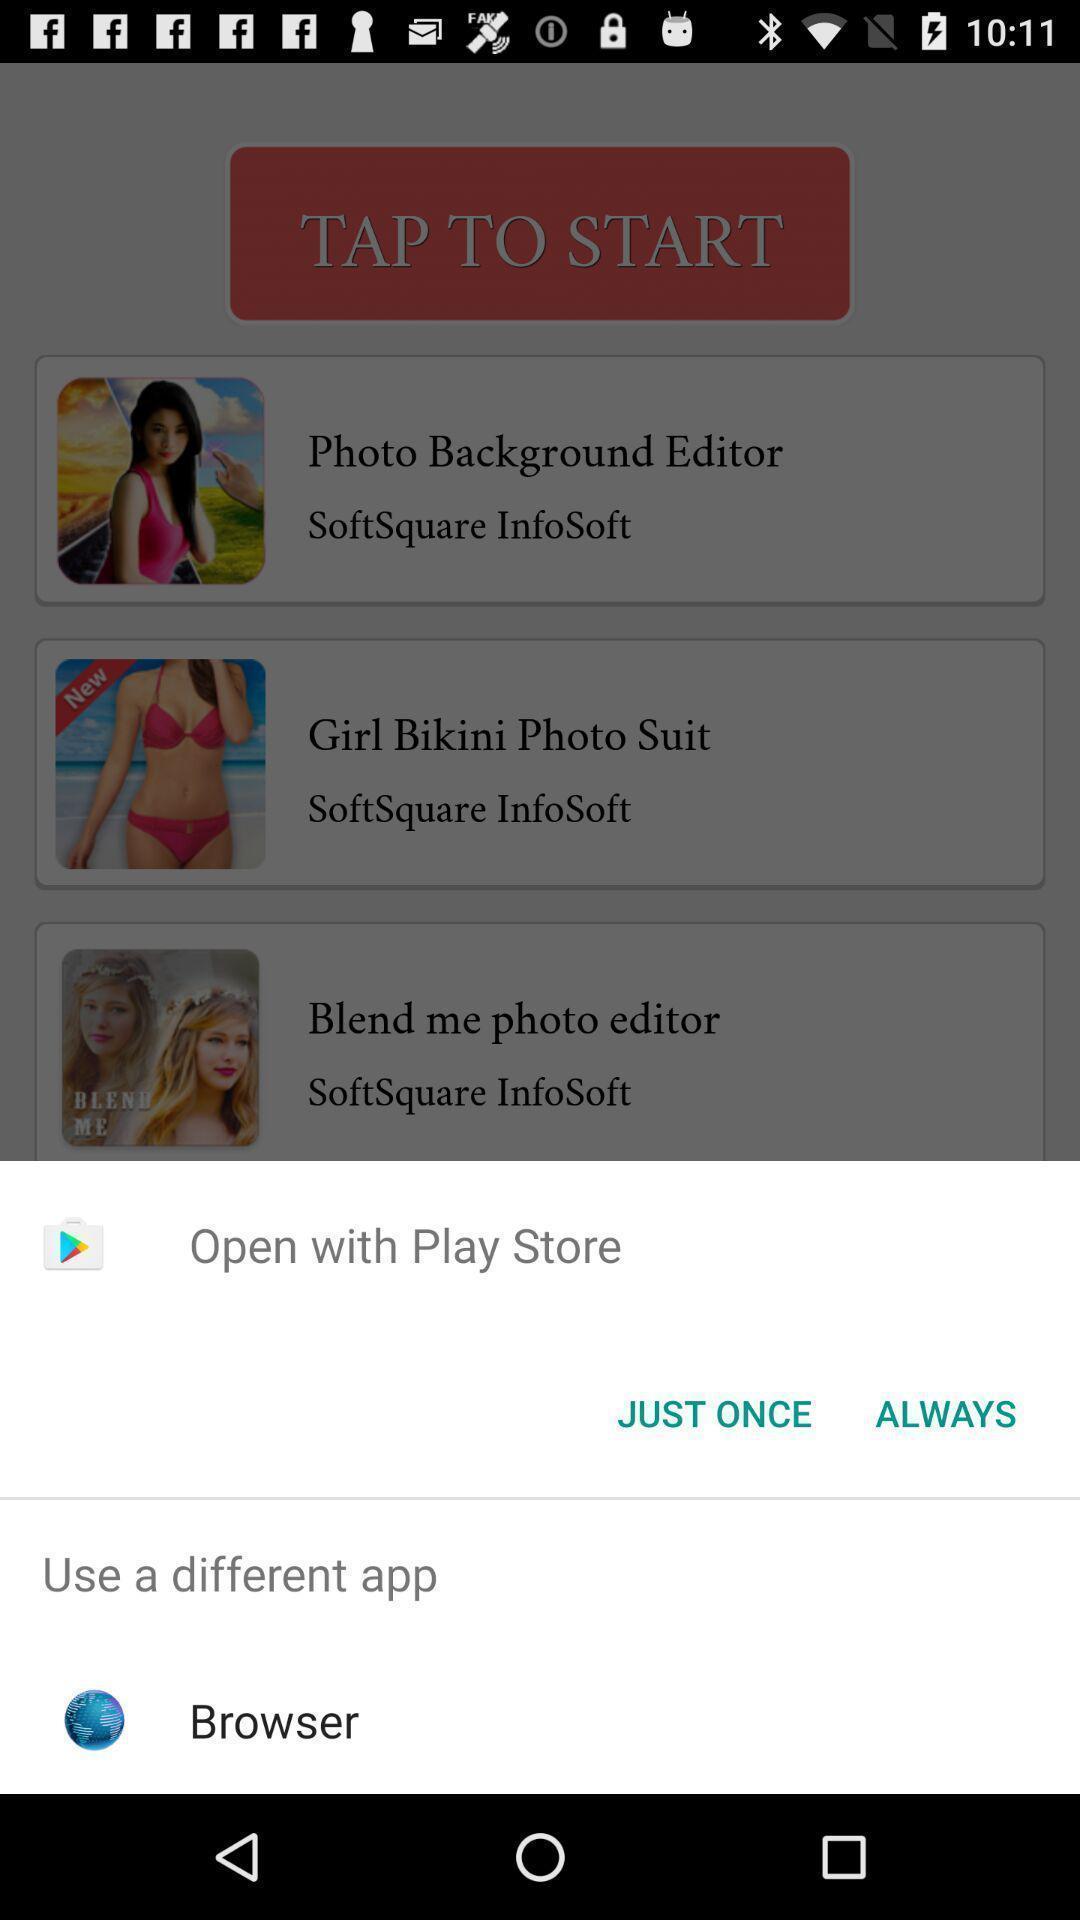Provide a detailed account of this screenshot. Pop-up displaying different applications to open. 